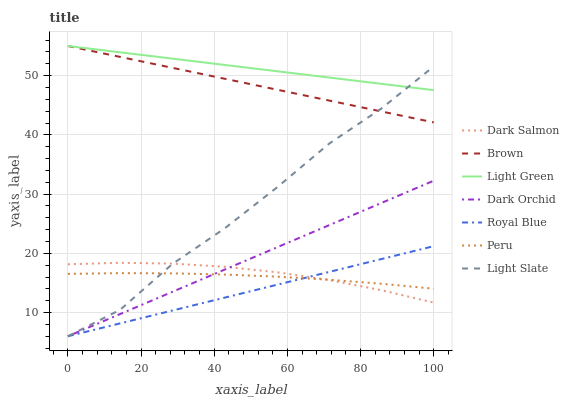Does Royal Blue have the minimum area under the curve?
Answer yes or no. Yes. Does Light Green have the maximum area under the curve?
Answer yes or no. Yes. Does Light Slate have the minimum area under the curve?
Answer yes or no. No. Does Light Slate have the maximum area under the curve?
Answer yes or no. No. Is Brown the smoothest?
Answer yes or no. Yes. Is Light Slate the roughest?
Answer yes or no. Yes. Is Light Green the smoothest?
Answer yes or no. No. Is Light Green the roughest?
Answer yes or no. No. Does Light Slate have the lowest value?
Answer yes or no. Yes. Does Light Green have the lowest value?
Answer yes or no. No. Does Light Green have the highest value?
Answer yes or no. Yes. Does Light Slate have the highest value?
Answer yes or no. No. Is Peru less than Light Green?
Answer yes or no. Yes. Is Light Green greater than Peru?
Answer yes or no. Yes. Does Light Green intersect Brown?
Answer yes or no. Yes. Is Light Green less than Brown?
Answer yes or no. No. Is Light Green greater than Brown?
Answer yes or no. No. Does Peru intersect Light Green?
Answer yes or no. No. 